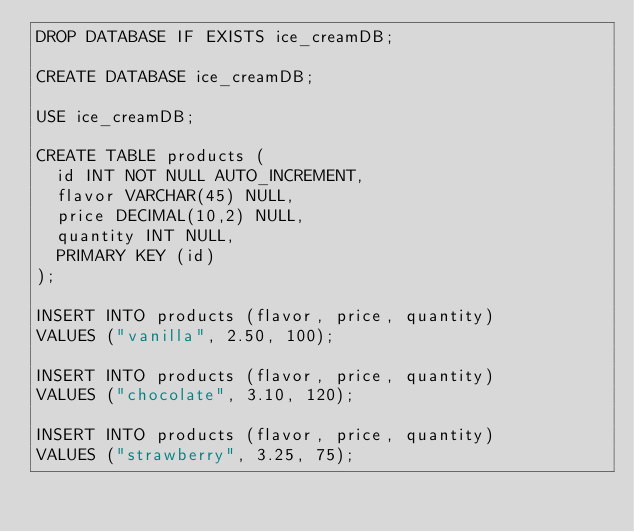<code> <loc_0><loc_0><loc_500><loc_500><_SQL_>DROP DATABASE IF EXISTS ice_creamDB;

CREATE DATABASE ice_creamDB;

USE ice_creamDB;

CREATE TABLE products (
  id INT NOT NULL AUTO_INCREMENT,
  flavor VARCHAR(45) NULL,
  price DECIMAL(10,2) NULL,
  quantity INT NULL,
  PRIMARY KEY (id)
);

INSERT INTO products (flavor, price, quantity)
VALUES ("vanilla", 2.50, 100);

INSERT INTO products (flavor, price, quantity)
VALUES ("chocolate", 3.10, 120);

INSERT INTO products (flavor, price, quantity)
VALUES ("strawberry", 3.25, 75);</code> 